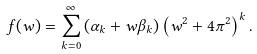Convert formula to latex. <formula><loc_0><loc_0><loc_500><loc_500>f ( w ) = \sum _ { k = 0 } ^ { \infty } \left ( \alpha _ { k } + w \beta _ { k } \right ) \left ( w ^ { 2 } + 4 \pi ^ { 2 } \right ) ^ { k } .</formula> 